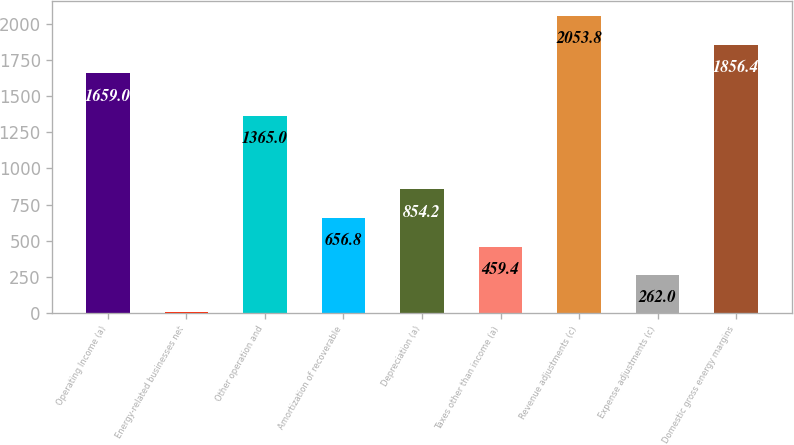Convert chart to OTSL. <chart><loc_0><loc_0><loc_500><loc_500><bar_chart><fcel>Operating Income (a)<fcel>Energy-related businesses net<fcel>Other operation and<fcel>Amortization of recoverable<fcel>Depreciation (a)<fcel>Taxes other than income (a)<fcel>Revenue adjustments (c)<fcel>Expense adjustments (c)<fcel>Domestic gross energy margins<nl><fcel>1659<fcel>7<fcel>1365<fcel>656.8<fcel>854.2<fcel>459.4<fcel>2053.8<fcel>262<fcel>1856.4<nl></chart> 